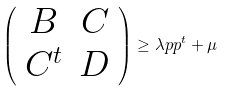Convert formula to latex. <formula><loc_0><loc_0><loc_500><loc_500>\left ( \begin{array} { c c } B & C \\ C ^ { t } & D \end{array} \right ) \geq \lambda p p ^ { t } + \mu</formula> 